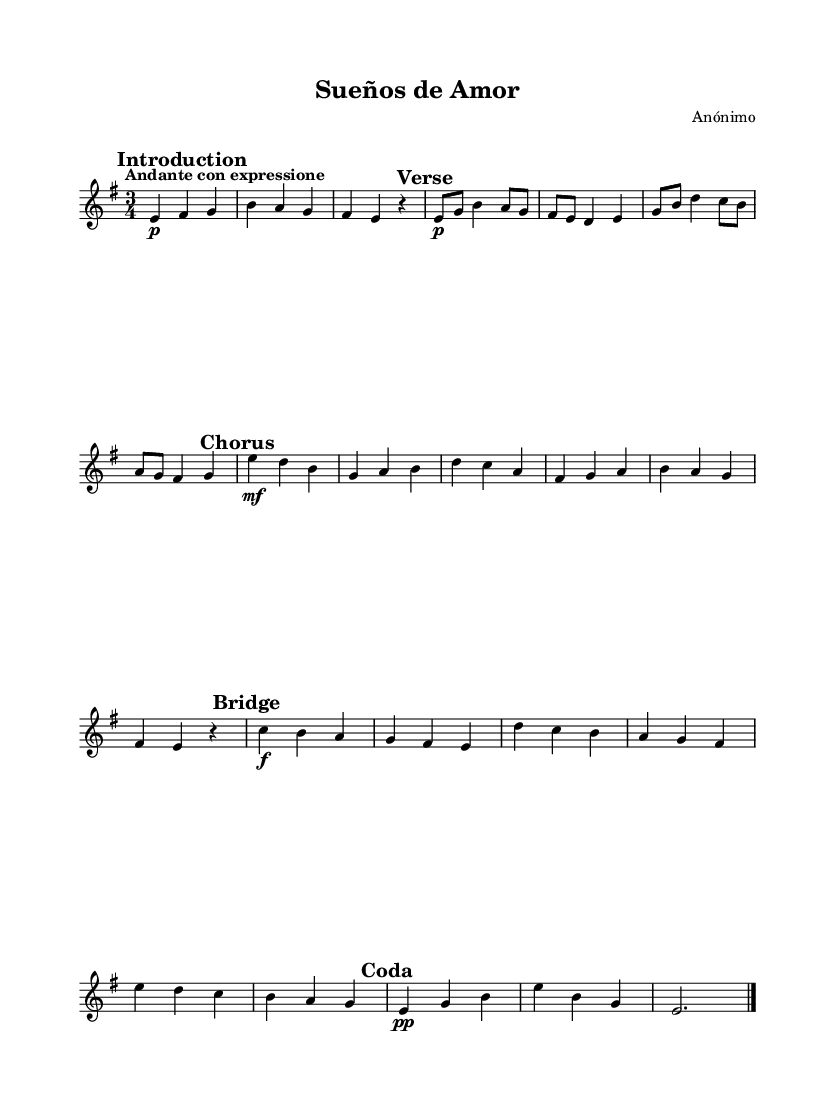What is the time signature of this music? The time signature is located at the beginning of the sheet music, where it shows "3/4". This indicates that there are three beats per measure and a quarter note gets one beat.
Answer: 3/4 What key is this piece composed in? The key signature appears at the beginning of the music, which shows E minor (indicated by one sharp, F#). The presence of an E minor key is further confirmed by the harmonic character of the chords and notes used throughout the piece.
Answer: E minor What is the tempo marking of this composition? The tempo marking "Andante con espressione" is given at the start of the piece. "Andante" generally implies a moderate walking pace, and "con espressione" indicates that the performance should be expressive, enhancing the emotional quality of the music.
Answer: Andante con espressione How many sections does this music have? By examining the structure noted in the score, we see specific markings like "Introduction," "Verse," "Chorus," "Bridge," and "Coda," which indicates that the piece has five distinct sections.
Answer: 5 What dynamic marking is indicated for the Chorus? In the Chorus section, the dynamic marking is "mf" (mezzo-forte), which indicates a medium loudness. This marking is written directly above the notes in that section, guiding the performer on how to express that part of the piece.
Answer: mf What instrument is indicated for this score? The score specifies "acoustic guitar (nylon)" at the beginning, which informs the performer about which instrument should be played. This detail suggests that the piece is intended for classical guitar performance.
Answer: acoustic guitar (nylon) What mood does the title "Sueños de Amor" suggest about the theme of the composition? The title "Sueños de Amor," which translates to "Dreams of Love," evokes themes of romance and longing. This title sets the emotional tone for the piece, reflecting the emotive quality typically found in Romantic compositions.
Answer: Romance 